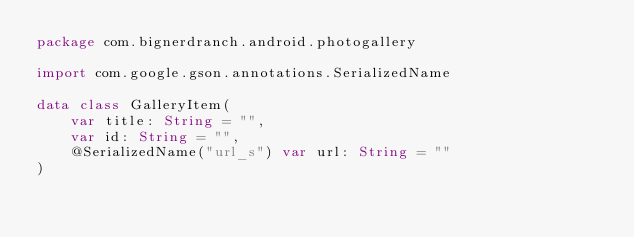Convert code to text. <code><loc_0><loc_0><loc_500><loc_500><_Kotlin_>package com.bignerdranch.android.photogallery

import com.google.gson.annotations.SerializedName

data class GalleryItem(
    var title: String = "",
    var id: String = "",
    @SerializedName("url_s") var url: String = ""
)</code> 